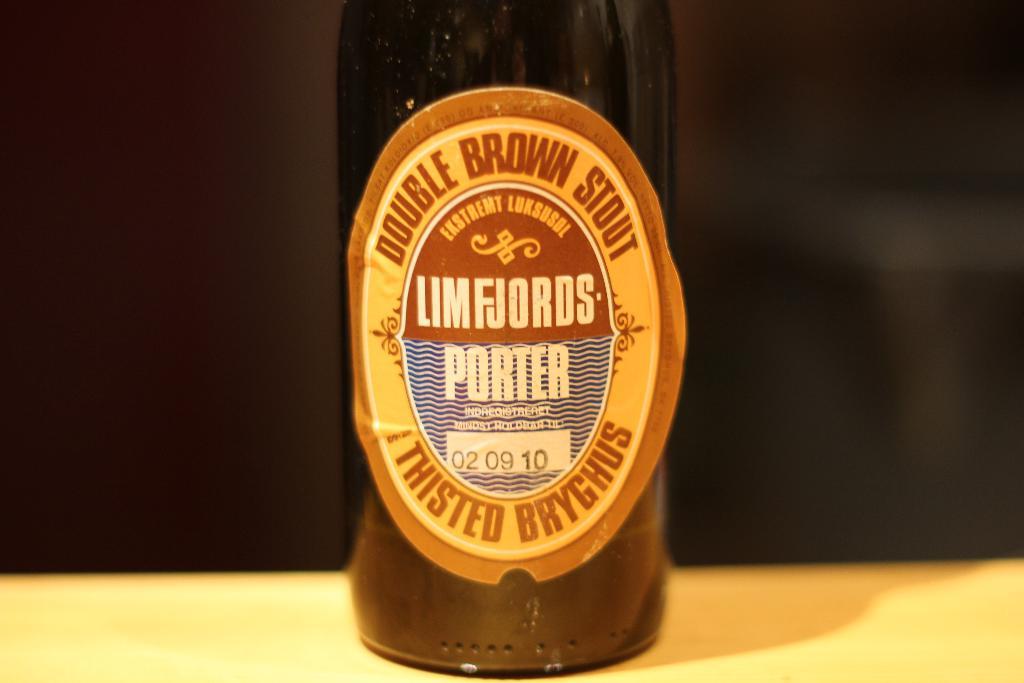What date is on the bottle?
Your answer should be compact. 02 09 10. 